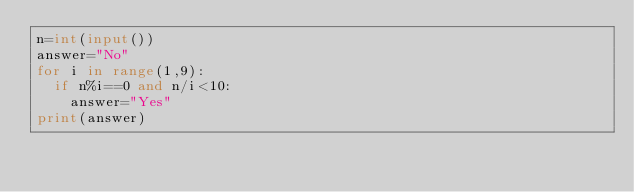Convert code to text. <code><loc_0><loc_0><loc_500><loc_500><_Python_>n=int(input())
answer="No"
for i in range(1,9):
  if n%i==0 and n/i<10:
    answer="Yes"
print(answer)</code> 